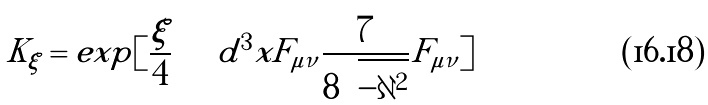Convert formula to latex. <formula><loc_0><loc_0><loc_500><loc_500>K _ { \xi } = e x p [ \frac { \xi } { 4 } \int d ^ { 3 } x F _ { \mu \nu } \frac { 7 } { 8 \sqrt { - \partial ^ { 2 } } } F _ { \mu \nu } ]</formula> 